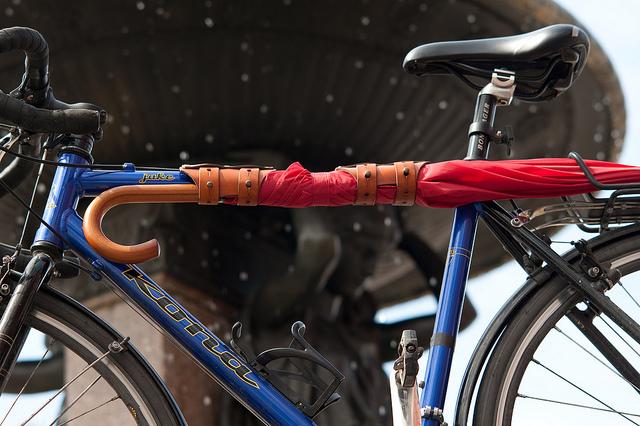How is the umbrella attached to the bike?
Keep it brief. Straps. What does the bike have attached to it?
Quick response, please. Umbrella. Is it raining?
Quick response, please. No. 